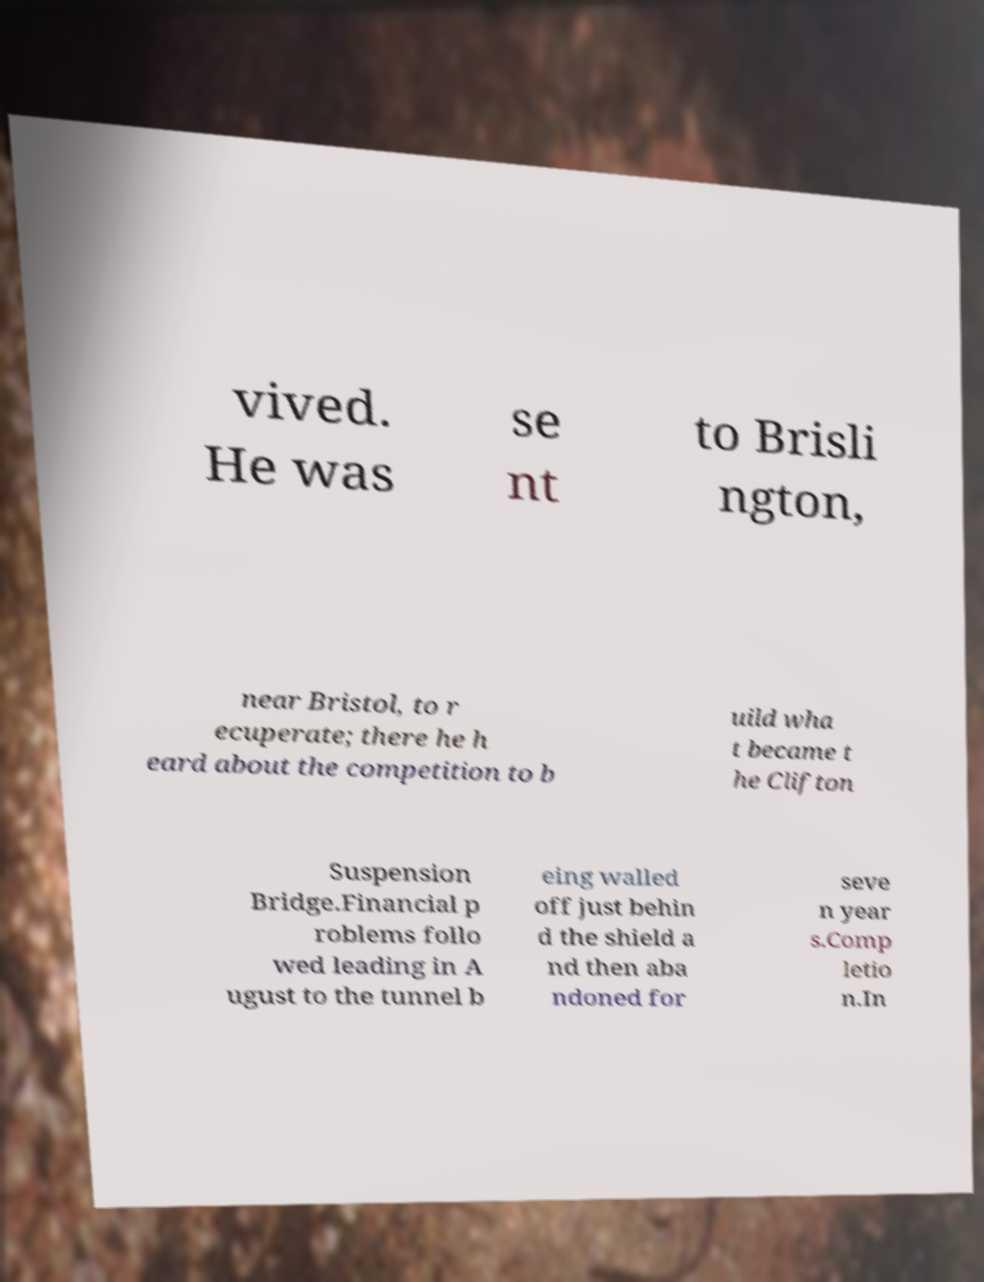For documentation purposes, I need the text within this image transcribed. Could you provide that? vived. He was se nt to Brisli ngton, near Bristol, to r ecuperate; there he h eard about the competition to b uild wha t became t he Clifton Suspension Bridge.Financial p roblems follo wed leading in A ugust to the tunnel b eing walled off just behin d the shield a nd then aba ndoned for seve n year s.Comp letio n.In 